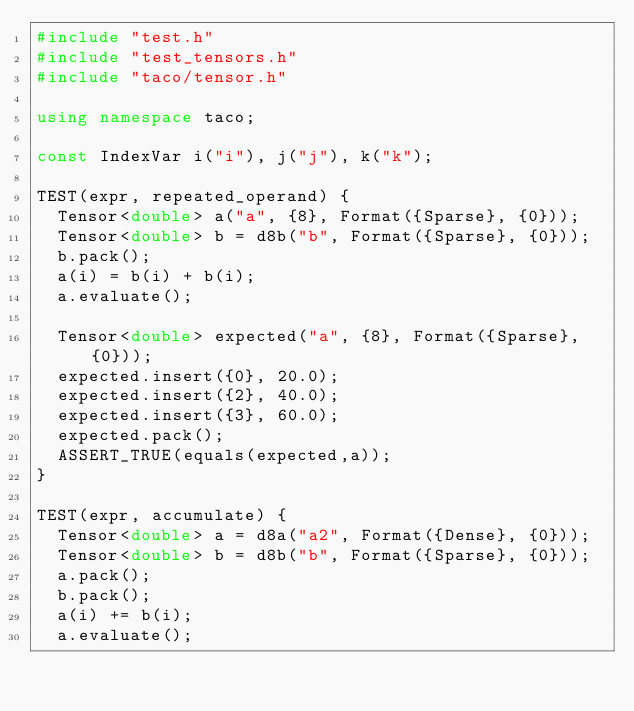Convert code to text. <code><loc_0><loc_0><loc_500><loc_500><_C++_>#include "test.h"
#include "test_tensors.h"
#include "taco/tensor.h"

using namespace taco;

const IndexVar i("i"), j("j"), k("k");

TEST(expr, repeated_operand) {
  Tensor<double> a("a", {8}, Format({Sparse}, {0}));
  Tensor<double> b = d8b("b", Format({Sparse}, {0}));
  b.pack();
  a(i) = b(i) + b(i);
  a.evaluate();

  Tensor<double> expected("a", {8}, Format({Sparse}, {0}));
  expected.insert({0}, 20.0);
  expected.insert({2}, 40.0);
  expected.insert({3}, 60.0);
  expected.pack();
  ASSERT_TRUE(equals(expected,a));
}

TEST(expr, accumulate) {
  Tensor<double> a = d8a("a2", Format({Dense}, {0}));
  Tensor<double> b = d8b("b", Format({Sparse}, {0}));
  a.pack();
  b.pack();
  a(i) += b(i);
  a.evaluate();
</code> 